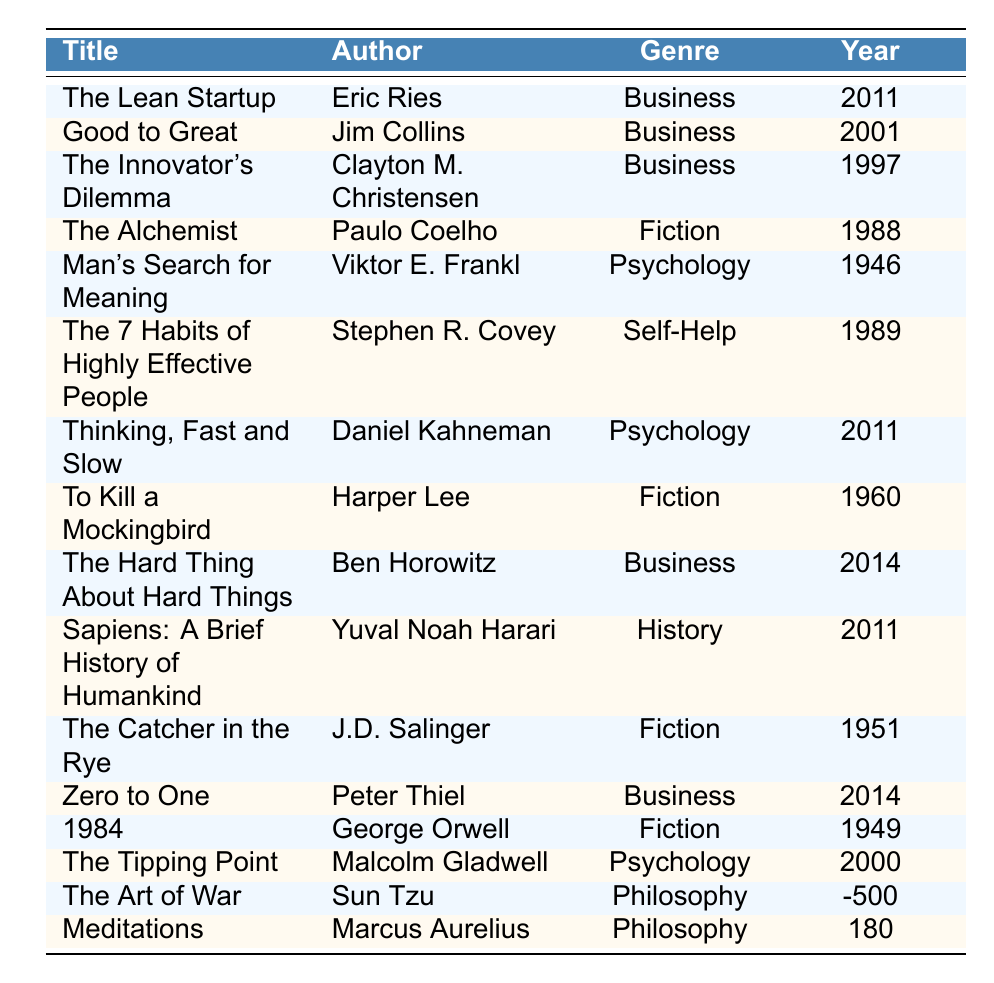What is the title of the book authored by Viktor E. Frankl? The table shows that Viktor E. Frankl authored the book titled "Man's Search for Meaning."
Answer: Man's Search for Meaning Which genre has the most recent publication year? The most recent publication years presented in the table are for the Business genre, which includes "The Hard Thing About Hard Things" and "Zero to One," both published in 2014.
Answer: Business Is "The Alchemist" written by Paulo Coelho? Referring to the table, it confirms that "The Alchemist" is indeed written by Paulo Coelho.
Answer: Yes How many books listed are from the Psychology genre? Counting the rows in the table that belong to the Psychology genre, there are three books: "Man's Search for Meaning," "Thinking, Fast and Slow," and "The Tipping Point."
Answer: 3 What is the average publication year of the books in the Fiction genre? The publication years for the Fiction genre are 1988, 1960, 1951, and 1949. Summing these gives 1988 + 1960 + 1951 + 1949 = 7859. To find the average, divide by the number of books, which is 4, resulting in 7859/4 = 1964.75. The average year rounds to 1965.
Answer: 1965 Which author has written the oldest book in this list? The table lists "The Art of War" by Sun Tzu with a publication year of -500, which is the oldest year presented.
Answer: Sun Tzu Are there any books published before 2000 in the Psychology genre? Examining the Psychology genre books, "Man's Search for Meaning" (1946) and "The Tipping Point" (2000) are in the table. Since 1946 is before 2000, the answer is yes.
Answer: Yes How many distinct genres are represented in the table? The genres in the table are Business, Fiction, Psychology, Self-Help, History, and Philosophy. Counting these gives a total of six distinct genres.
Answer: 6 Which books belong to the Business genre and what are their publication years? The table indicates that the Business genre includes "The Lean Startup" (2011), "Good to Great" (2001), "The Innovator's Dilemma" (1997), "The Hard Thing About Hard Things" (2014), and "Zero to One" (2014).
Answer: The Lean Startup (2011), Good to Great (2001), The Innovator's Dilemma (1997), The Hard Thing About Hard Things (2014), Zero to One (2014) Which author has written the most books in this list? Checking the table shows that no author has multiple entries. Each listed author is unique. Thus, everyone has written one book.
Answer: None 